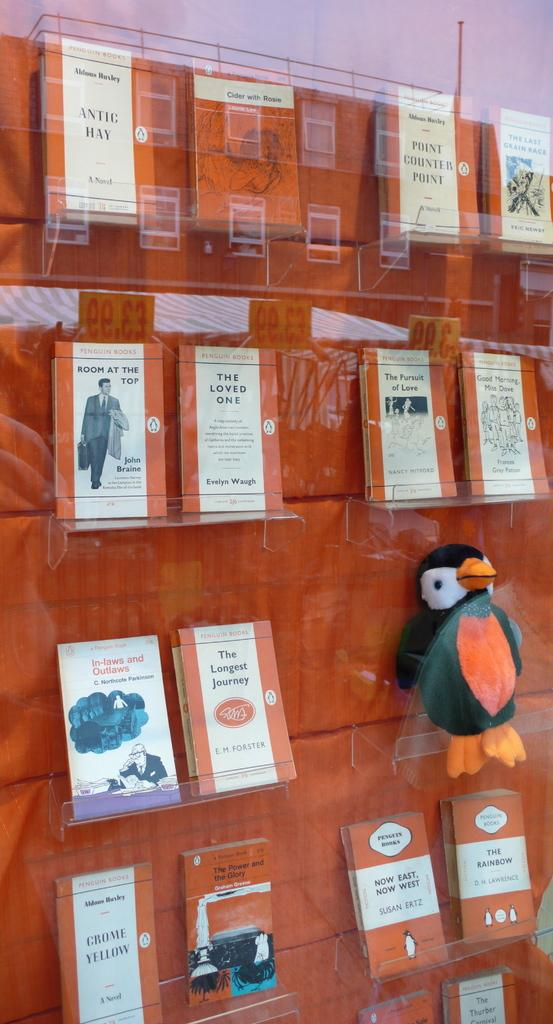What objects can be seen in the image? There are books in the image. How are the books arranged or stored? The books are in glass racks. Are there any other notable objects in the image? Yes, there is a doll in the shape of a bird on the right side of the image. What type of mist can be seen surrounding the books in the image? There is no mist present in the image; the books are in glass racks. 